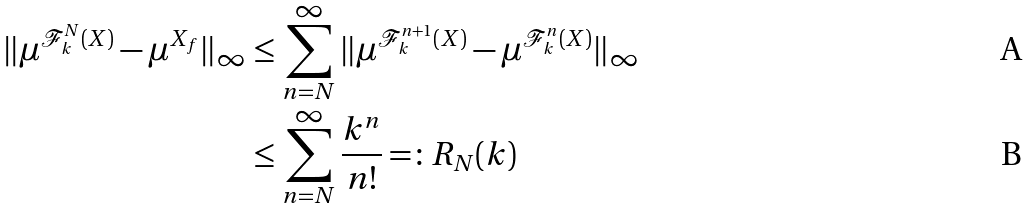Convert formula to latex. <formula><loc_0><loc_0><loc_500><loc_500>\| \mu ^ { \mathcal { F } _ { k } ^ { N } ( X ) } - \mu ^ { X _ { f } } \| _ { \infty } & \leq \sum _ { n = N } ^ { \infty } \| \mu ^ { \mathcal { F } _ { k } ^ { n + 1 } ( X ) } - \mu ^ { \mathcal { F } _ { k } ^ { n } ( X ) } \| _ { \infty } \\ & \leq \sum _ { n = N } ^ { \infty } \frac { k ^ { n } } { n ! } = \colon R _ { N } ( k )</formula> 